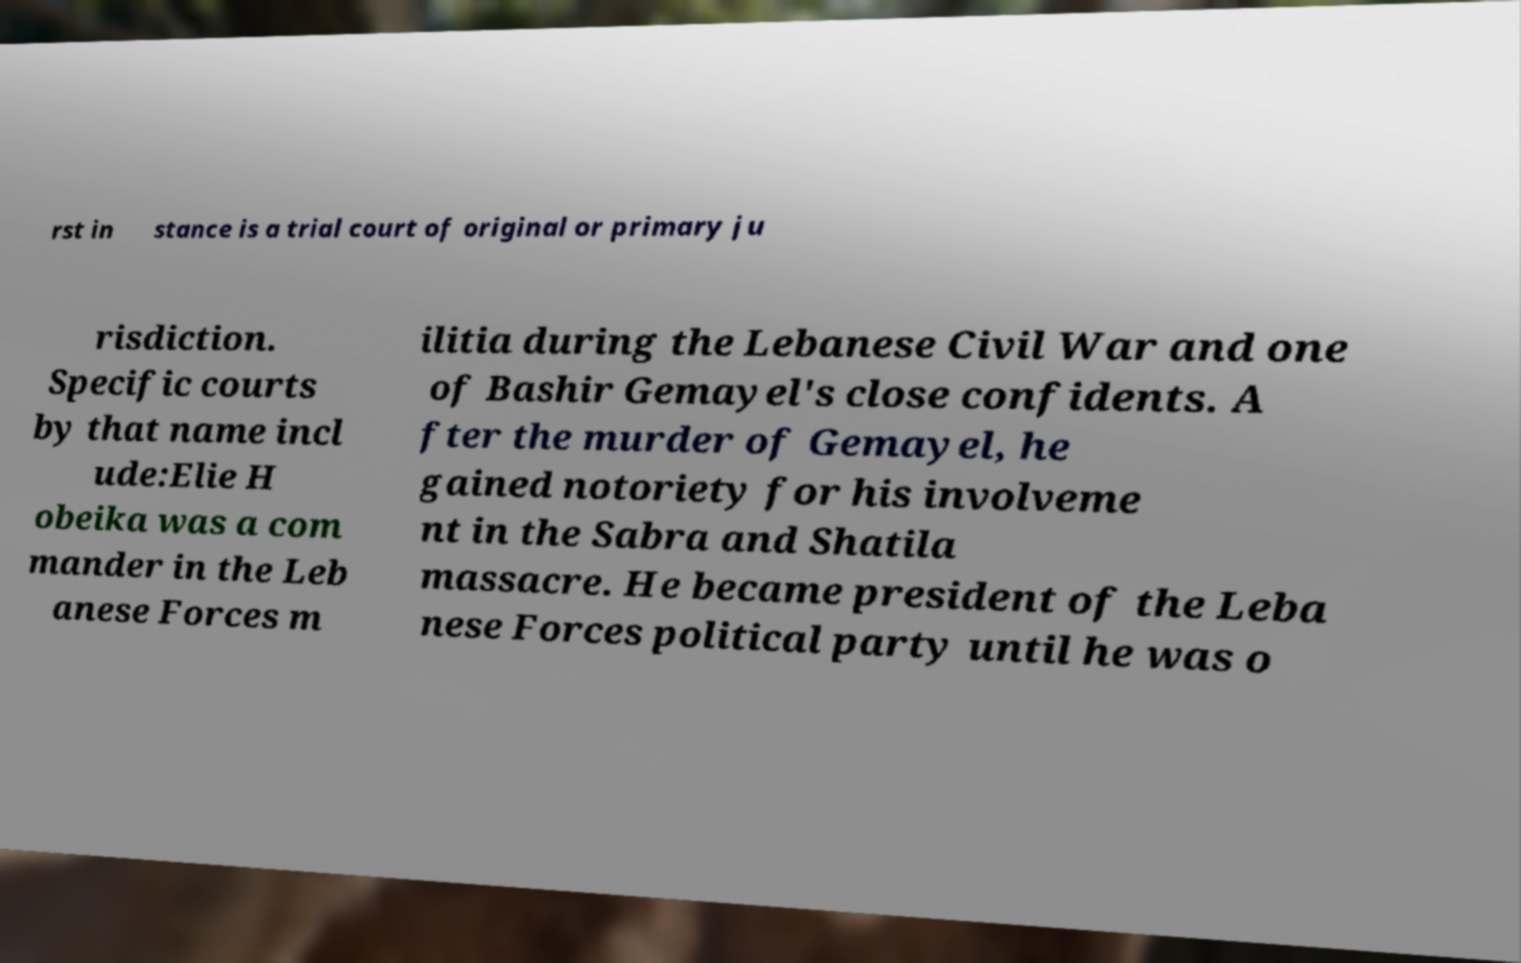Could you assist in decoding the text presented in this image and type it out clearly? rst in stance is a trial court of original or primary ju risdiction. Specific courts by that name incl ude:Elie H obeika was a com mander in the Leb anese Forces m ilitia during the Lebanese Civil War and one of Bashir Gemayel's close confidents. A fter the murder of Gemayel, he gained notoriety for his involveme nt in the Sabra and Shatila massacre. He became president of the Leba nese Forces political party until he was o 